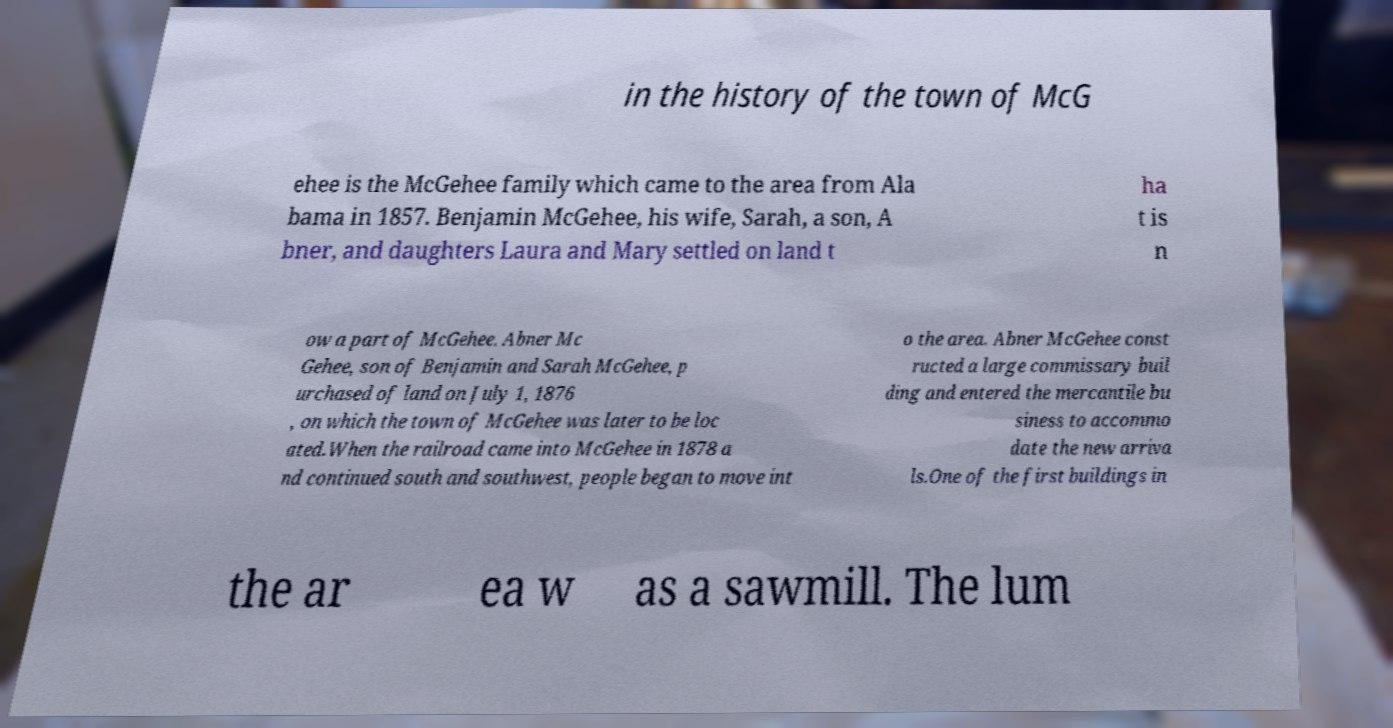For documentation purposes, I need the text within this image transcribed. Could you provide that? in the history of the town of McG ehee is the McGehee family which came to the area from Ala bama in 1857. Benjamin McGehee, his wife, Sarah, a son, A bner, and daughters Laura and Mary settled on land t ha t is n ow a part of McGehee. Abner Mc Gehee, son of Benjamin and Sarah McGehee, p urchased of land on July 1, 1876 , on which the town of McGehee was later to be loc ated.When the railroad came into McGehee in 1878 a nd continued south and southwest, people began to move int o the area. Abner McGehee const ructed a large commissary buil ding and entered the mercantile bu siness to accommo date the new arriva ls.One of the first buildings in the ar ea w as a sawmill. The lum 